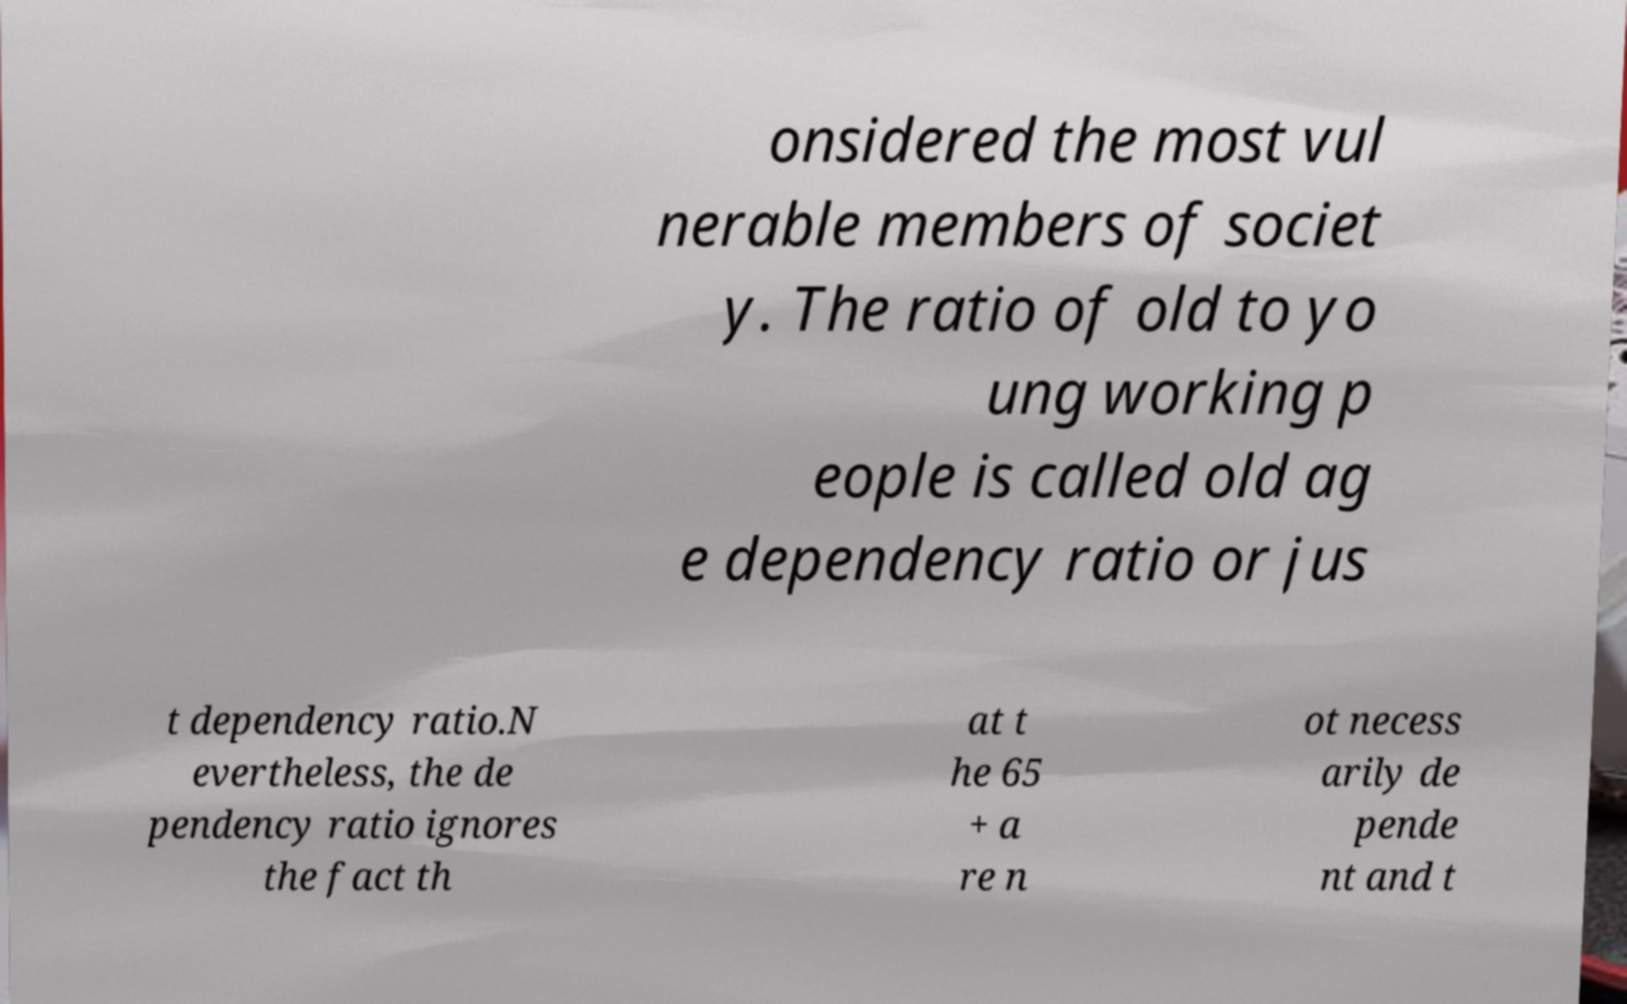For documentation purposes, I need the text within this image transcribed. Could you provide that? onsidered the most vul nerable members of societ y. The ratio of old to yo ung working p eople is called old ag e dependency ratio or jus t dependency ratio.N evertheless, the de pendency ratio ignores the fact th at t he 65 + a re n ot necess arily de pende nt and t 